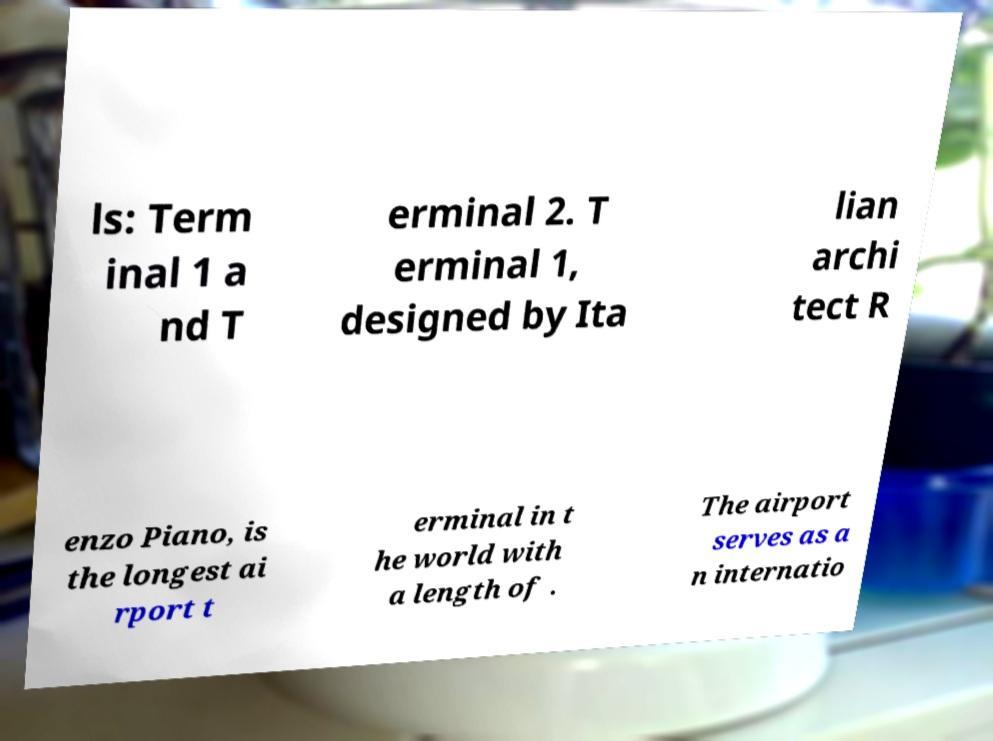Please identify and transcribe the text found in this image. ls: Term inal 1 a nd T erminal 2. T erminal 1, designed by Ita lian archi tect R enzo Piano, is the longest ai rport t erminal in t he world with a length of . The airport serves as a n internatio 